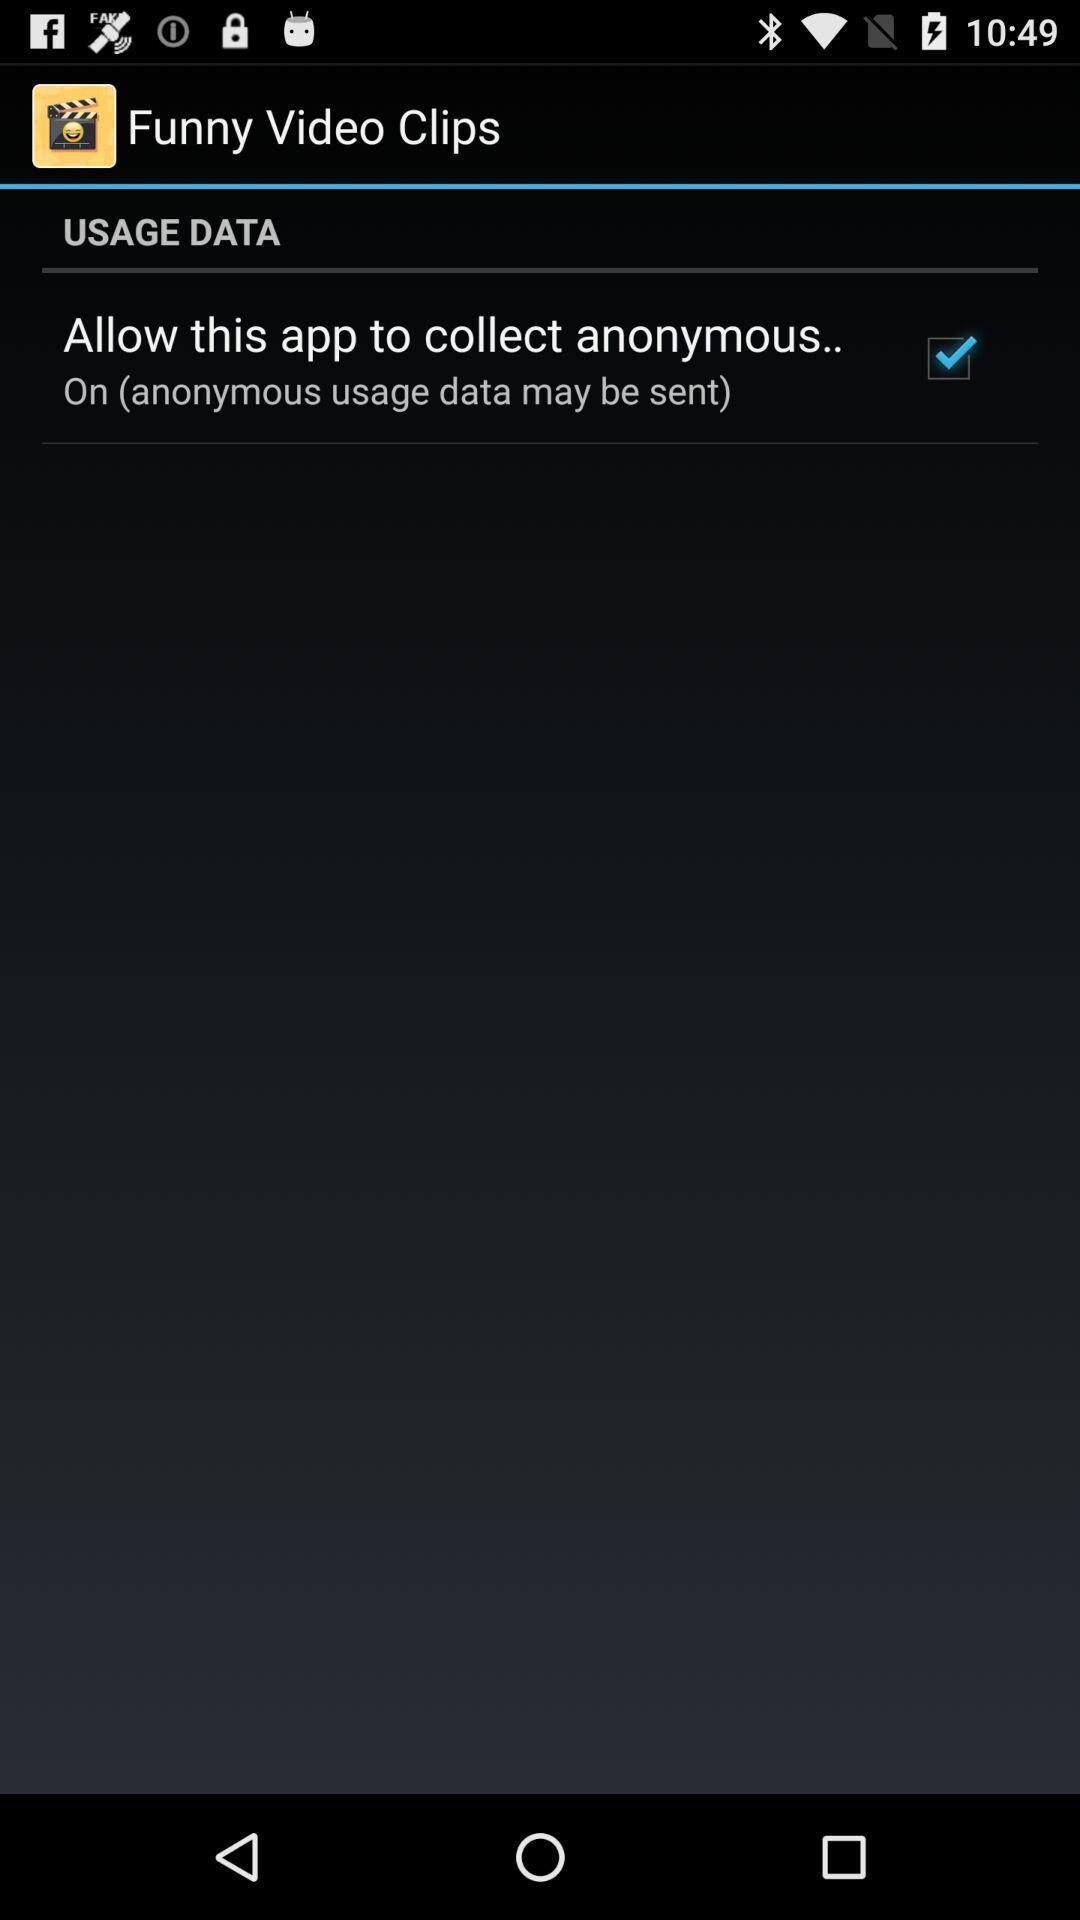What is the overall content of this screenshot? Page displaying usage data option. 